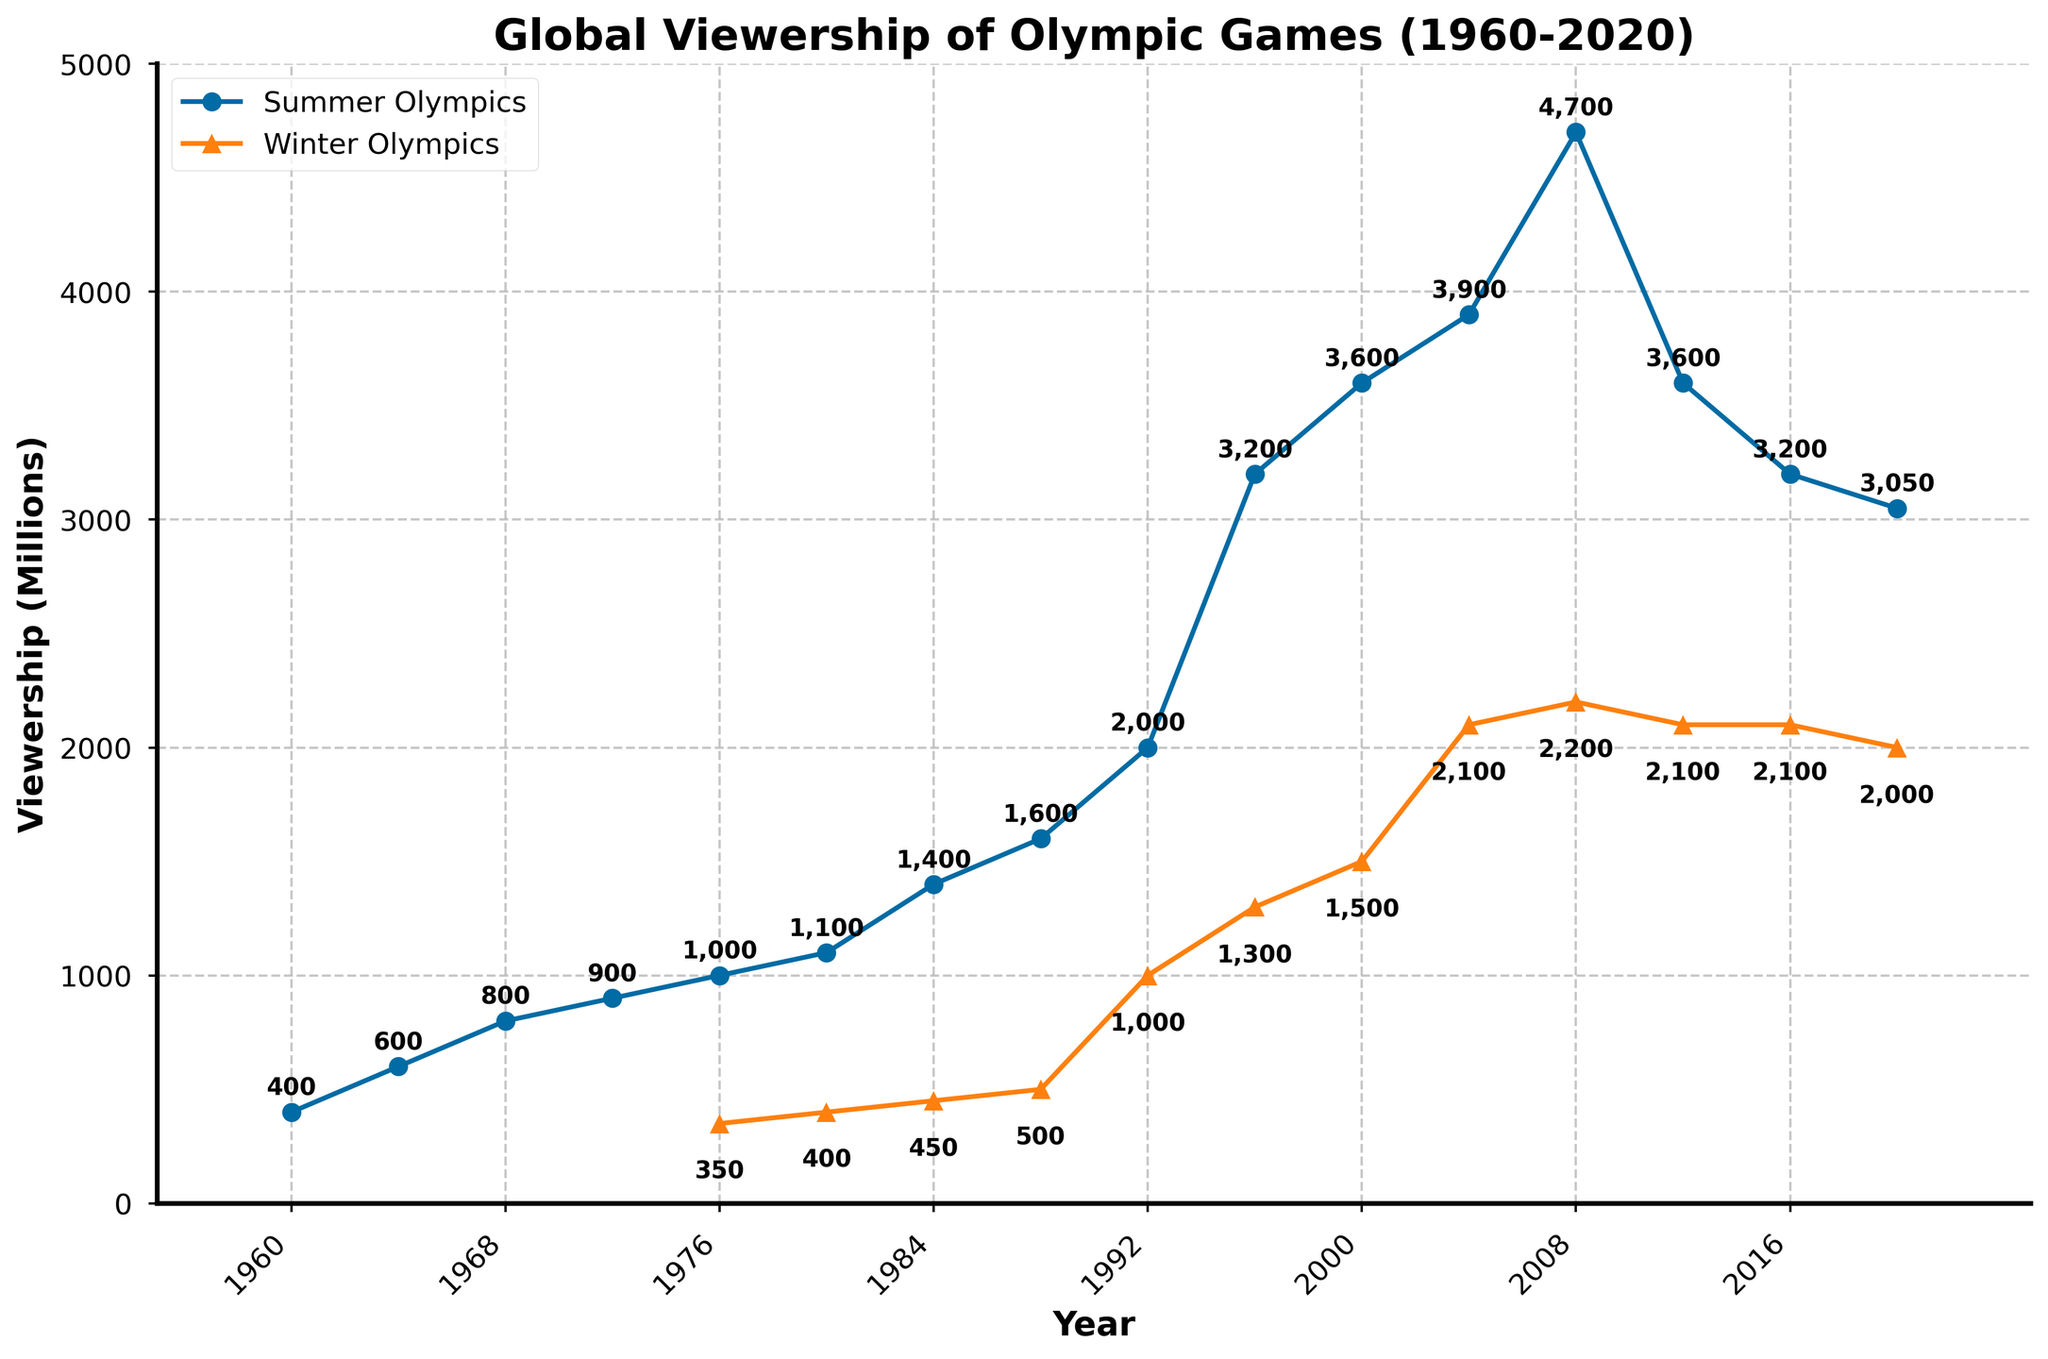What is the viewership difference between the Summer and Winter Olympics in 2020? The viewership for the Summer Olympics in 2020 is 3050 million, and for the Winter Olympics, it is 2000 million. The difference is 3050 - 2000 = 1050 million.
Answer: 1050 million Which year had the highest viewership for the Summer Olympics? By inspecting the Summer Olympics line (solid line with circles), the highest point is in 2008 with a viewership of 4700 million.
Answer: 2008 What was the average viewership for the Winter Olympics between 1992 and 2020? Calculate the average by summing the viewership figures for the Winter Olympics between 1992 and 2020 and dividing by the number of data points. The sum is 1000 + 1300 + 1500 + 2100 + 2200 + 2100 + 2100 + 2000 = 14300. The number of data points is 8. So, 14300 / 8 = 1787.5 million.
Answer: 1787.5 million In which year did the Winter Olympics viewership first reach 1000 million? Inspecting the Winter Olympics line (dashed line with triangles), the first year it reached 1000 million is in 1992.
Answer: 1992 What is the trend in Summer Olympics viewership from 1960 to 2020? The trend is upward overall, starting from 400 million in 1960 and peaking at 4700 million in 2008 before showing a slight decline down to 3050 million in 2020.
Answer: Upward with recent decline In which year is the gap between the Summer and Winter Olympics viewership the smallest? The smallest gap can be found by visually inspecting the proximity of the two lines. In 2012, the Summer Olympics viewership is 3600 million, and the Winter Olympics viewership is 2100 million, making the gap 1500 million, which appears relatively small compared to other years.
Answer: 2012 How many times has the Summer Olympics viewership decreased compared to the previous games? Compare the viewership values year by year: the Summer Olympics viewership decreased from 4700 million in 2008 to 3600 million in 2012, then to 3200 million in 2016, and again to 3050 million in 2020. This is a total of 3 times.
Answer: 3 times What is the percentage increase in Winter Olympics viewership from 1984 to 1992? The viewership increased from 450 million in 1984 to 1000 million in 1992. The percentage increase is calculated as ((1000 - 450) / 450) * 100 = 122.22%.
Answer: 122.22% Which year saw the largest single-year increase in Summer Olympics viewership? View the differences between consecutive years: the largest increase is from 1992 (2000 million) to 1996 (3200 million), an increase of 1200 million.
Answer: 1992 to 1996 